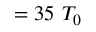<formula> <loc_0><loc_0><loc_500><loc_500>= 3 5 T _ { 0 }</formula> 